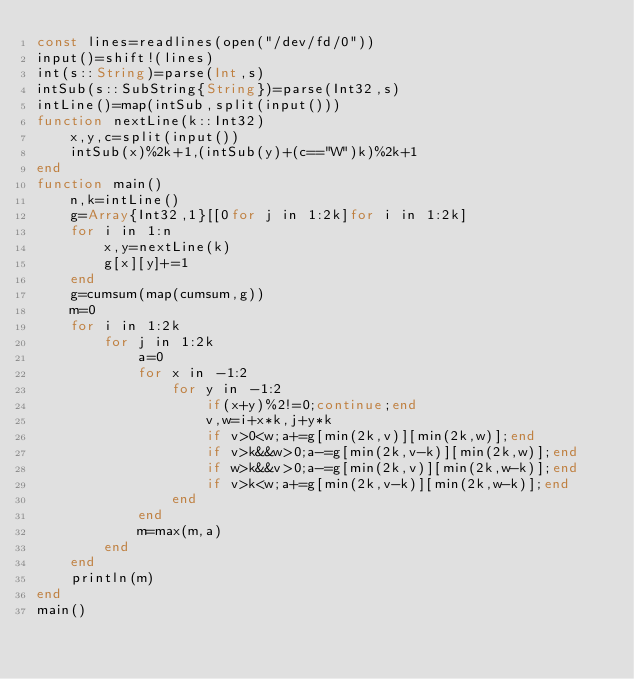Convert code to text. <code><loc_0><loc_0><loc_500><loc_500><_Julia_>const lines=readlines(open("/dev/fd/0"))
input()=shift!(lines)
int(s::String)=parse(Int,s)
intSub(s::SubString{String})=parse(Int32,s)
intLine()=map(intSub,split(input()))
function nextLine(k::Int32)
    x,y,c=split(input())
    intSub(x)%2k+1,(intSub(y)+(c=="W")k)%2k+1
end
function main()
    n,k=intLine()
    g=Array{Int32,1}[[0for j in 1:2k]for i in 1:2k]
    for i in 1:n
        x,y=nextLine(k)
        g[x][y]+=1
    end
    g=cumsum(map(cumsum,g))
    m=0
    for i in 1:2k
        for j in 1:2k
            a=0
            for x in -1:2
                for y in -1:2
                    if(x+y)%2!=0;continue;end
                    v,w=i+x*k,j+y*k
                    if v>0<w;a+=g[min(2k,v)][min(2k,w)];end
                    if v>k&&w>0;a-=g[min(2k,v-k)][min(2k,w)];end
                    if w>k&&v>0;a-=g[min(2k,v)][min(2k,w-k)];end
                    if v>k<w;a+=g[min(2k,v-k)][min(2k,w-k)];end
                end
            end
            m=max(m,a)
        end
    end
    println(m)
end
main()</code> 